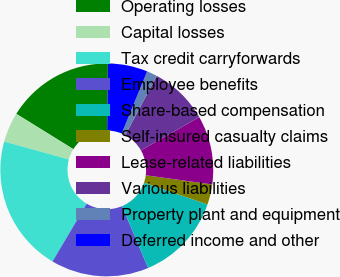Convert chart. <chart><loc_0><loc_0><loc_500><loc_500><pie_chart><fcel>Operating losses<fcel>Capital losses<fcel>Tax credit carryforwards<fcel>Employee benefits<fcel>Share-based compensation<fcel>Self-insured casualty claims<fcel>Lease-related liabilities<fcel>Various liabilities<fcel>Property plant and equipment<fcel>Deferred income and other<nl><fcel>16.34%<fcel>4.54%<fcel>20.77%<fcel>14.87%<fcel>13.39%<fcel>3.07%<fcel>10.44%<fcel>8.97%<fcel>1.59%<fcel>6.02%<nl></chart> 